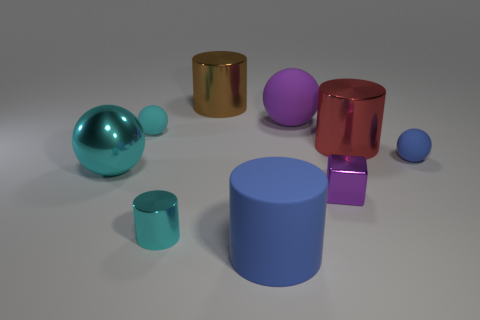Subtract all small metal cylinders. How many cylinders are left? 3 Subtract 1 cylinders. How many cylinders are left? 3 Subtract all red cylinders. How many cylinders are left? 3 Subtract all green balls. Subtract all blue cubes. How many balls are left? 4 Add 1 cyan cylinders. How many objects exist? 10 Subtract all spheres. How many objects are left? 5 Subtract 0 gray cylinders. How many objects are left? 9 Subtract all small gray cylinders. Subtract all red metal cylinders. How many objects are left? 8 Add 3 cyan objects. How many cyan objects are left? 6 Add 4 tiny yellow matte cubes. How many tiny yellow matte cubes exist? 4 